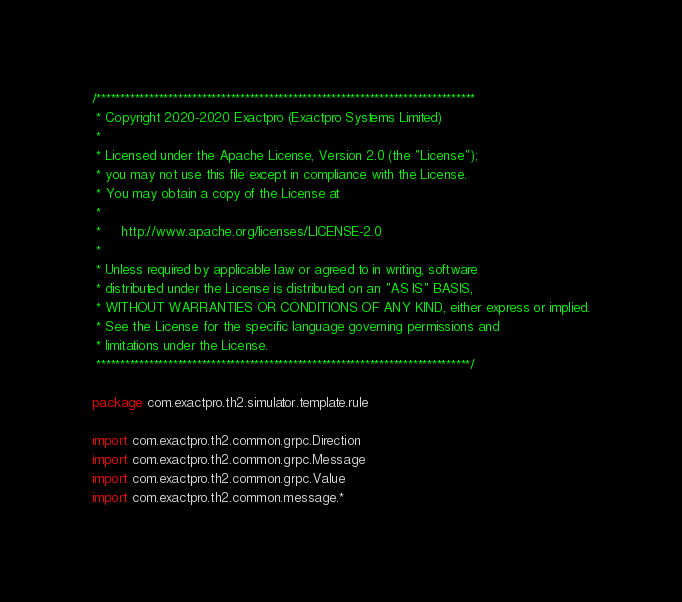<code> <loc_0><loc_0><loc_500><loc_500><_Kotlin_>/*******************************************************************************
 * Copyright 2020-2020 Exactpro (Exactpro Systems Limited)
 *
 * Licensed under the Apache License, Version 2.0 (the "License");
 * you may not use this file except in compliance with the License.
 * You may obtain a copy of the License at
 *
 *     http://www.apache.org/licenses/LICENSE-2.0
 *
 * Unless required by applicable law or agreed to in writing, software
 * distributed under the License is distributed on an "AS IS" BASIS,
 * WITHOUT WARRANTIES OR CONDITIONS OF ANY KIND, either express or implied.
 * See the License for the specific language governing permissions and
 * limitations under the License.
 ******************************************************************************/

package com.exactpro.th2.simulator.template.rule

import com.exactpro.th2.common.grpc.Direction
import com.exactpro.th2.common.grpc.Message
import com.exactpro.th2.common.grpc.Value
import com.exactpro.th2.common.message.*</code> 